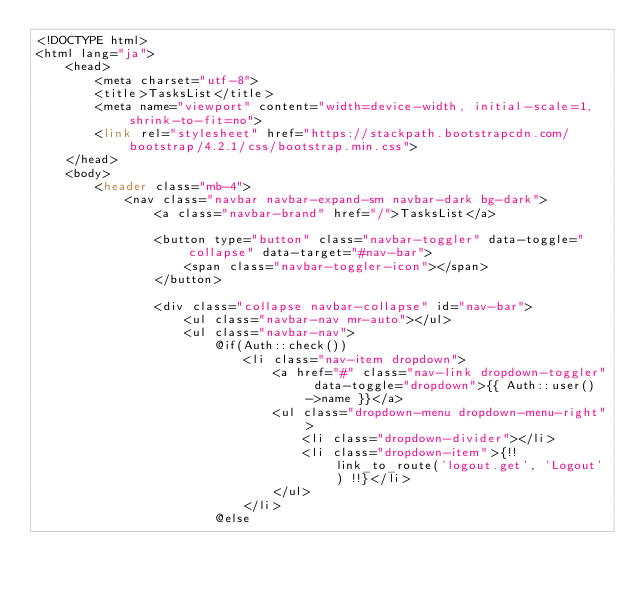<code> <loc_0><loc_0><loc_500><loc_500><_PHP_><!DOCTYPE html>
<html lang="ja">
    <head>
        <meta charset="utf-8">
        <title>TasksList</title>
        <meta name="viewport" content="width=device-width, initial-scale=1, shrink-to-fit=no">
        <link rel="stylesheet" href="https://stackpath.bootstrapcdn.com/bootstrap/4.2.1/css/bootstrap.min.css">
    </head>
    <body>
        <header class="mb-4">
            <nav class="navbar navbar-expand-sm navbar-dark bg-dark">
                <a class="navbar-brand" href="/">TasksList</a>
                
                <button type="button" class="navbar-toggler" data-toggle="collapse" data-target="#nav-bar">
                    <span class="navbar-toggler-icon"></span>
                </button>
                
                <div class="collapse navbar-collapse" id="nav-bar">
                    <ul class="navbar-nav mr-auto"></ul>
                    <ul class="navbar-nav">
                        @if(Auth::check())
                            <li class="nav-item dropdown">
                                <a href="#" class="nav-link dropdown-toggler" data-toggle="dropdown">{{ Auth::user()->name }}</a>
                                <ul class="dropdown-menu dropdown-menu-right">
                                    <li class="dropdown-divider"></li>
                                    <li class="dropdown-item">{!! link_to_route('logout.get', 'Logout') !!}</li>
                                </ul>
                            </li>
                        @else</code> 